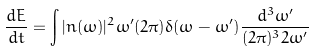Convert formula to latex. <formula><loc_0><loc_0><loc_500><loc_500>\frac { d E } { d t } = \int | n ( \omega ) | ^ { 2 } \omega ^ { \prime } ( 2 \pi ) \delta ( \omega - \omega ^ { \prime } ) \frac { d ^ { 3 } \omega ^ { \prime } } { ( 2 \pi ) ^ { 3 } 2 \omega ^ { \prime } }</formula> 